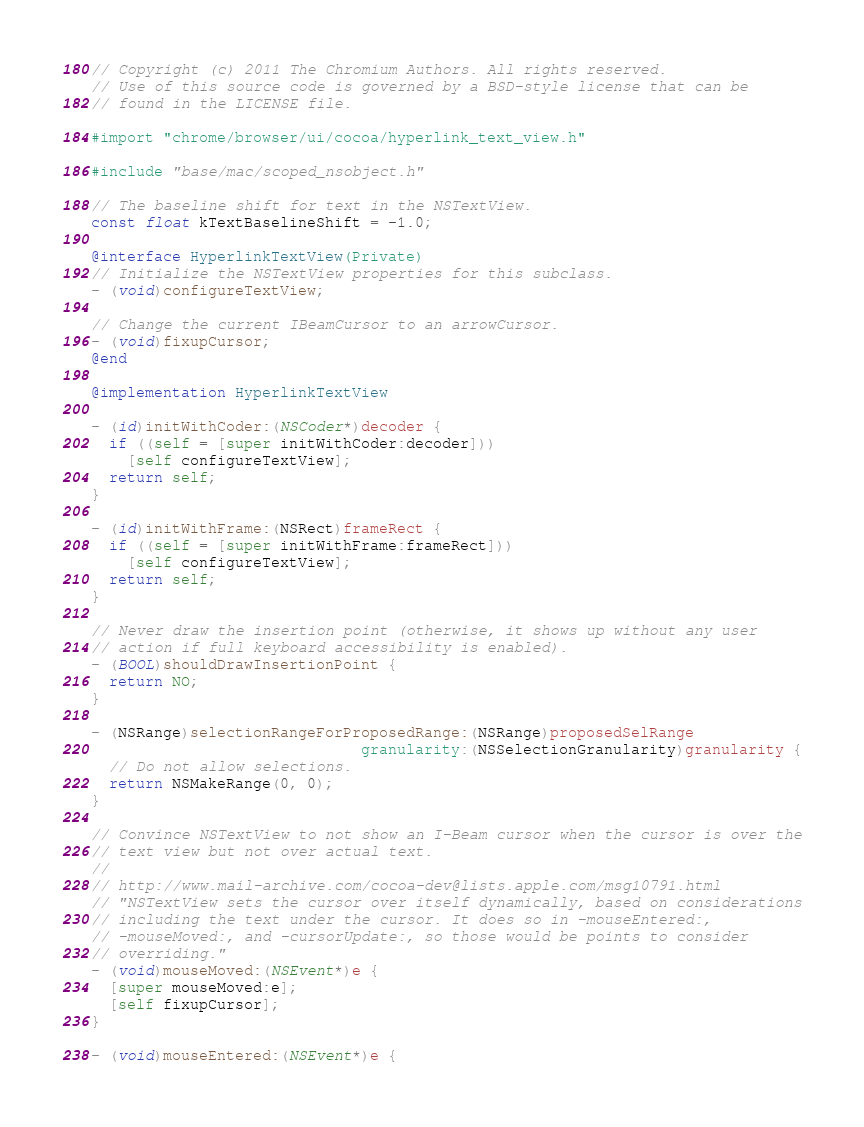<code> <loc_0><loc_0><loc_500><loc_500><_ObjectiveC_>// Copyright (c) 2011 The Chromium Authors. All rights reserved.
// Use of this source code is governed by a BSD-style license that can be
// found in the LICENSE file.

#import "chrome/browser/ui/cocoa/hyperlink_text_view.h"

#include "base/mac/scoped_nsobject.h"

// The baseline shift for text in the NSTextView.
const float kTextBaselineShift = -1.0;

@interface HyperlinkTextView(Private)
// Initialize the NSTextView properties for this subclass.
- (void)configureTextView;

// Change the current IBeamCursor to an arrowCursor.
- (void)fixupCursor;
@end

@implementation HyperlinkTextView

- (id)initWithCoder:(NSCoder*)decoder {
  if ((self = [super initWithCoder:decoder]))
    [self configureTextView];
  return self;
}

- (id)initWithFrame:(NSRect)frameRect {
  if ((self = [super initWithFrame:frameRect]))
    [self configureTextView];
  return self;
}

// Never draw the insertion point (otherwise, it shows up without any user
// action if full keyboard accessibility is enabled).
- (BOOL)shouldDrawInsertionPoint {
  return NO;
}

- (NSRange)selectionRangeForProposedRange:(NSRange)proposedSelRange
                              granularity:(NSSelectionGranularity)granularity {
  // Do not allow selections.
  return NSMakeRange(0, 0);
}

// Convince NSTextView to not show an I-Beam cursor when the cursor is over the
// text view but not over actual text.
//
// http://www.mail-archive.com/cocoa-dev@lists.apple.com/msg10791.html
// "NSTextView sets the cursor over itself dynamically, based on considerations
// including the text under the cursor. It does so in -mouseEntered:,
// -mouseMoved:, and -cursorUpdate:, so those would be points to consider
// overriding."
- (void)mouseMoved:(NSEvent*)e {
  [super mouseMoved:e];
  [self fixupCursor];
}

- (void)mouseEntered:(NSEvent*)e {</code> 